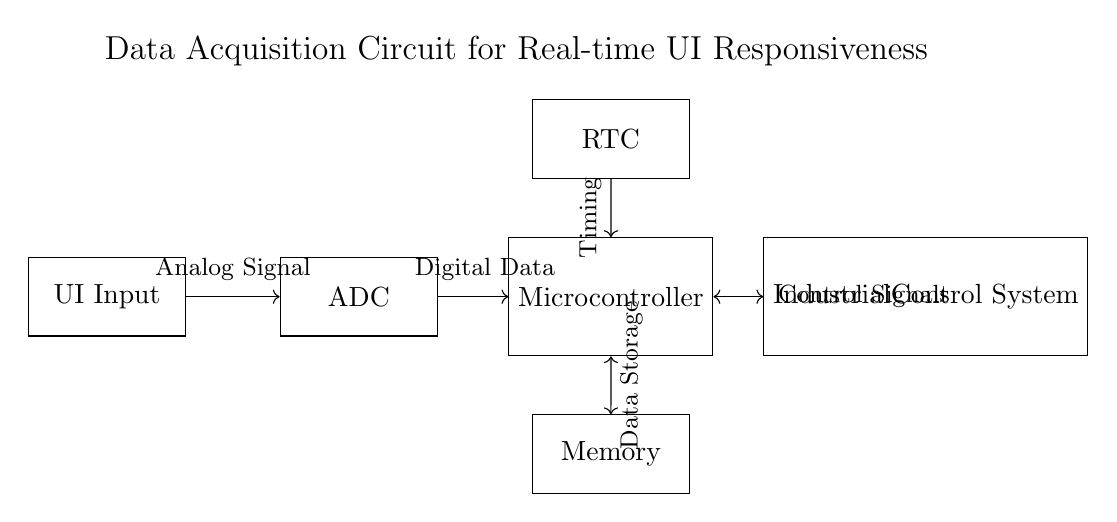What is the main purpose of the circuit? The main purpose of the circuit is to facilitate data acquisition for real-time user interface responsiveness in industrial control systems. This is indicated by the title of the circuit diagram.
Answer: Data acquisition What component converts analog signals to digital data? The component responsible for converting analog signals to digital data is the Analog-to-Digital Converter (ADC). It is the second block in the flow of the circuit, following the UI Input.
Answer: ADC How many main components are present in the circuit? The circuit consists of five main components, which are the UI Input, ADC, Microcontroller, RTC, and Memory. Each is depicted as a rectangle in the diagram.
Answer: Five Which component is directly responsible for timekeeping in the circuit? The Real-Time Clock (RTC) is the component that provides timing information to the system, as shown in its position above the Microcontroller in the diagram.
Answer: RTC What does the Microcontroller communicate with both in terms of data transmission? The Microcontroller communicates with the Memory for data storage and with the Industrial Control System for control signals, based on the bidirectional arrows shown in the diagram.
Answer: Memory and Industrial Control System What type of signal does the UI Input provide to the ADC? The UI Input sends an analog signal to the ADC, which is depicted by the directed arrow connecting these two components in the circuit.
Answer: Analog signal What role does the Microcontroller serve in the overall circuit operation? The Microcontroller acts as the central processing unit that processes the digital data from the ADC and interacts with the RTC for timing and the Memory for data storage. It is the core component for controlling the system.
Answer: Central processing unit 